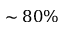Convert formula to latex. <formula><loc_0><loc_0><loc_500><loc_500>\sim 8 0 \%</formula> 